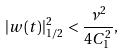<formula> <loc_0><loc_0><loc_500><loc_500>| w ( t ) | ^ { 2 } _ { 1 / 2 } \, < \frac { \nu ^ { 2 } } { 4 C ^ { 2 } _ { 1 } } ,</formula> 